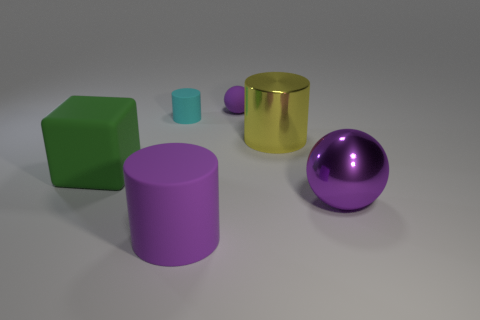Add 2 small spheres. How many objects exist? 8 Subtract all big cylinders. How many cylinders are left? 1 Add 5 big rubber things. How many big rubber things are left? 7 Add 2 gray metal things. How many gray metal things exist? 2 Subtract all cyan cylinders. How many cylinders are left? 2 Subtract 1 green blocks. How many objects are left? 5 Subtract all blocks. How many objects are left? 5 Subtract 2 cylinders. How many cylinders are left? 1 Subtract all yellow blocks. Subtract all green cylinders. How many blocks are left? 1 Subtract all purple balls. How many cyan cylinders are left? 1 